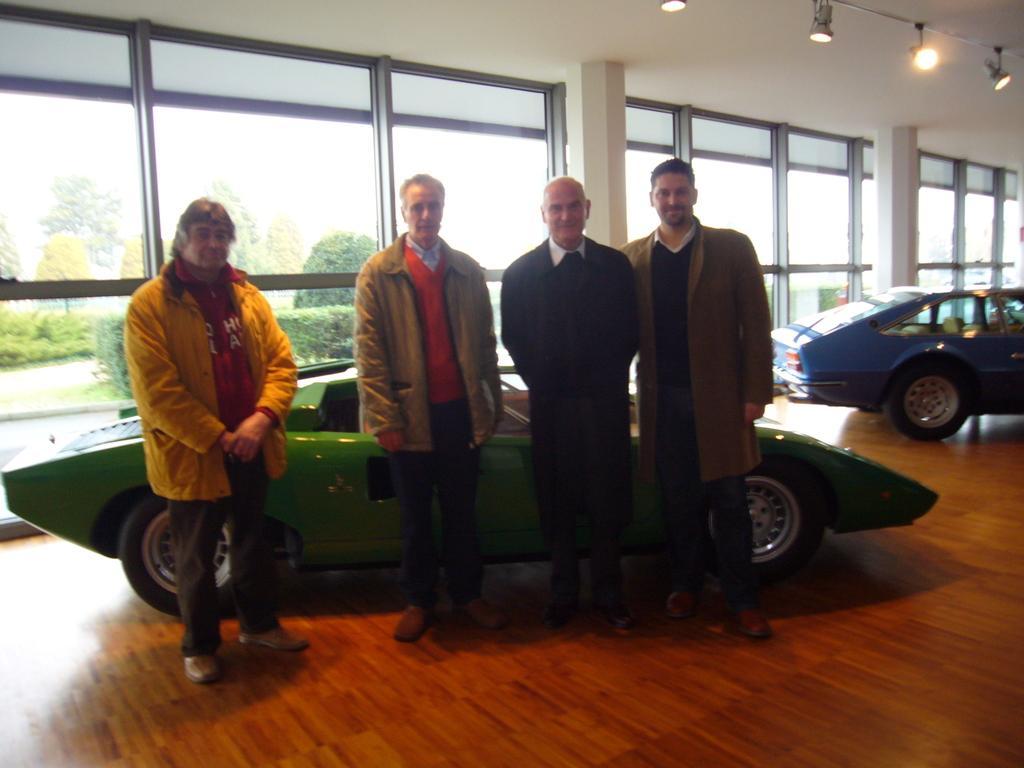Could you give a brief overview of what you see in this image? In the center of the image we can see four people are standing and they are in different costumes. Among them, we can see two people are smiling. In the background there is a wall, glass, floor, vehicles and lights. Through the glass, we can see trees. 